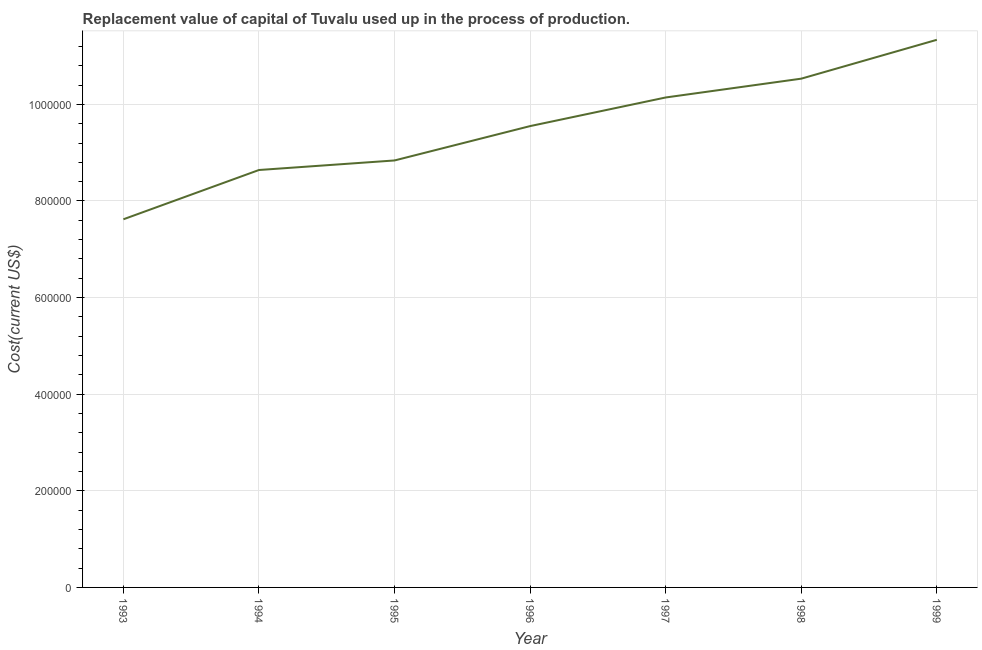What is the consumption of fixed capital in 1995?
Give a very brief answer. 8.84e+05. Across all years, what is the maximum consumption of fixed capital?
Your answer should be compact. 1.13e+06. Across all years, what is the minimum consumption of fixed capital?
Make the answer very short. 7.62e+05. In which year was the consumption of fixed capital minimum?
Provide a short and direct response. 1993. What is the sum of the consumption of fixed capital?
Your answer should be very brief. 6.67e+06. What is the difference between the consumption of fixed capital in 1994 and 1997?
Offer a very short reply. -1.50e+05. What is the average consumption of fixed capital per year?
Give a very brief answer. 9.52e+05. What is the median consumption of fixed capital?
Ensure brevity in your answer.  9.55e+05. Do a majority of the years between 1998 and 1996 (inclusive) have consumption of fixed capital greater than 800000 US$?
Make the answer very short. No. What is the ratio of the consumption of fixed capital in 1997 to that in 1998?
Ensure brevity in your answer.  0.96. Is the difference between the consumption of fixed capital in 1997 and 1998 greater than the difference between any two years?
Your answer should be very brief. No. What is the difference between the highest and the second highest consumption of fixed capital?
Make the answer very short. 8.05e+04. What is the difference between the highest and the lowest consumption of fixed capital?
Offer a very short reply. 3.72e+05. Does the consumption of fixed capital monotonically increase over the years?
Offer a terse response. Yes. How many lines are there?
Give a very brief answer. 1. How many years are there in the graph?
Your answer should be very brief. 7. What is the difference between two consecutive major ticks on the Y-axis?
Ensure brevity in your answer.  2.00e+05. Are the values on the major ticks of Y-axis written in scientific E-notation?
Your response must be concise. No. Does the graph contain grids?
Give a very brief answer. Yes. What is the title of the graph?
Provide a succinct answer. Replacement value of capital of Tuvalu used up in the process of production. What is the label or title of the Y-axis?
Provide a succinct answer. Cost(current US$). What is the Cost(current US$) in 1993?
Your answer should be compact. 7.62e+05. What is the Cost(current US$) of 1994?
Ensure brevity in your answer.  8.64e+05. What is the Cost(current US$) of 1995?
Provide a succinct answer. 8.84e+05. What is the Cost(current US$) in 1996?
Ensure brevity in your answer.  9.55e+05. What is the Cost(current US$) in 1997?
Give a very brief answer. 1.01e+06. What is the Cost(current US$) in 1998?
Keep it short and to the point. 1.05e+06. What is the Cost(current US$) of 1999?
Your answer should be compact. 1.13e+06. What is the difference between the Cost(current US$) in 1993 and 1994?
Keep it short and to the point. -1.02e+05. What is the difference between the Cost(current US$) in 1993 and 1995?
Your response must be concise. -1.22e+05. What is the difference between the Cost(current US$) in 1993 and 1996?
Make the answer very short. -1.93e+05. What is the difference between the Cost(current US$) in 1993 and 1997?
Offer a terse response. -2.52e+05. What is the difference between the Cost(current US$) in 1993 and 1998?
Offer a terse response. -2.91e+05. What is the difference between the Cost(current US$) in 1993 and 1999?
Keep it short and to the point. -3.72e+05. What is the difference between the Cost(current US$) in 1994 and 1995?
Keep it short and to the point. -1.98e+04. What is the difference between the Cost(current US$) in 1994 and 1996?
Keep it short and to the point. -9.09e+04. What is the difference between the Cost(current US$) in 1994 and 1997?
Keep it short and to the point. -1.50e+05. What is the difference between the Cost(current US$) in 1994 and 1998?
Provide a succinct answer. -1.89e+05. What is the difference between the Cost(current US$) in 1994 and 1999?
Provide a short and direct response. -2.70e+05. What is the difference between the Cost(current US$) in 1995 and 1996?
Keep it short and to the point. -7.11e+04. What is the difference between the Cost(current US$) in 1995 and 1997?
Offer a very short reply. -1.30e+05. What is the difference between the Cost(current US$) in 1995 and 1998?
Offer a terse response. -1.69e+05. What is the difference between the Cost(current US$) in 1995 and 1999?
Your response must be concise. -2.50e+05. What is the difference between the Cost(current US$) in 1996 and 1997?
Give a very brief answer. -5.92e+04. What is the difference between the Cost(current US$) in 1996 and 1998?
Your answer should be compact. -9.82e+04. What is the difference between the Cost(current US$) in 1996 and 1999?
Ensure brevity in your answer.  -1.79e+05. What is the difference between the Cost(current US$) in 1997 and 1998?
Provide a short and direct response. -3.89e+04. What is the difference between the Cost(current US$) in 1997 and 1999?
Your response must be concise. -1.19e+05. What is the difference between the Cost(current US$) in 1998 and 1999?
Provide a succinct answer. -8.05e+04. What is the ratio of the Cost(current US$) in 1993 to that in 1994?
Provide a succinct answer. 0.88. What is the ratio of the Cost(current US$) in 1993 to that in 1995?
Provide a succinct answer. 0.86. What is the ratio of the Cost(current US$) in 1993 to that in 1996?
Give a very brief answer. 0.8. What is the ratio of the Cost(current US$) in 1993 to that in 1997?
Keep it short and to the point. 0.75. What is the ratio of the Cost(current US$) in 1993 to that in 1998?
Keep it short and to the point. 0.72. What is the ratio of the Cost(current US$) in 1993 to that in 1999?
Your answer should be compact. 0.67. What is the ratio of the Cost(current US$) in 1994 to that in 1996?
Keep it short and to the point. 0.91. What is the ratio of the Cost(current US$) in 1994 to that in 1997?
Your answer should be compact. 0.85. What is the ratio of the Cost(current US$) in 1994 to that in 1998?
Ensure brevity in your answer.  0.82. What is the ratio of the Cost(current US$) in 1994 to that in 1999?
Make the answer very short. 0.76. What is the ratio of the Cost(current US$) in 1995 to that in 1996?
Your answer should be very brief. 0.93. What is the ratio of the Cost(current US$) in 1995 to that in 1997?
Provide a succinct answer. 0.87. What is the ratio of the Cost(current US$) in 1995 to that in 1998?
Offer a very short reply. 0.84. What is the ratio of the Cost(current US$) in 1995 to that in 1999?
Your response must be concise. 0.78. What is the ratio of the Cost(current US$) in 1996 to that in 1997?
Make the answer very short. 0.94. What is the ratio of the Cost(current US$) in 1996 to that in 1998?
Give a very brief answer. 0.91. What is the ratio of the Cost(current US$) in 1996 to that in 1999?
Your answer should be very brief. 0.84. What is the ratio of the Cost(current US$) in 1997 to that in 1998?
Your answer should be very brief. 0.96. What is the ratio of the Cost(current US$) in 1997 to that in 1999?
Your answer should be compact. 0.9. What is the ratio of the Cost(current US$) in 1998 to that in 1999?
Ensure brevity in your answer.  0.93. 